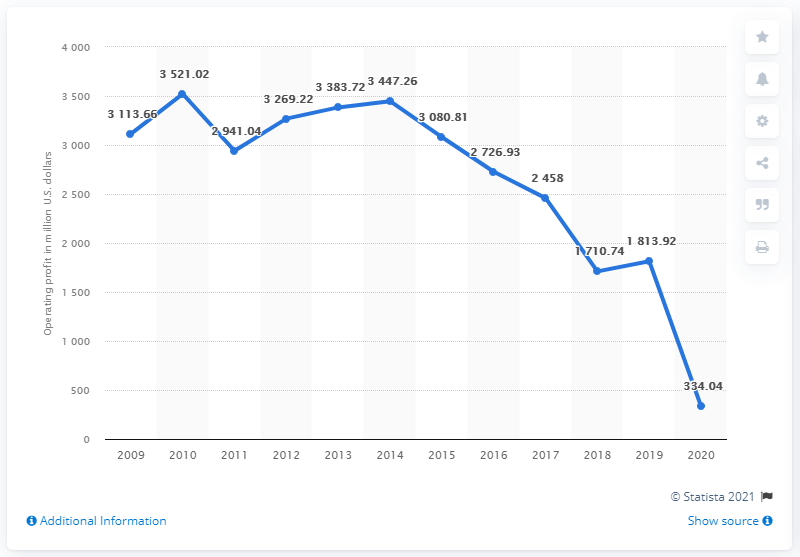Highlight a few significant elements in this photo. The global operating profit of the H&M Group in dollars in 2020 was 334.04. The average operating profit of the H&M Group worldwide from 2019 to 2020 was 1073.98. The operating profit of the H&M Group worldwide in 2020 was 334.04. 